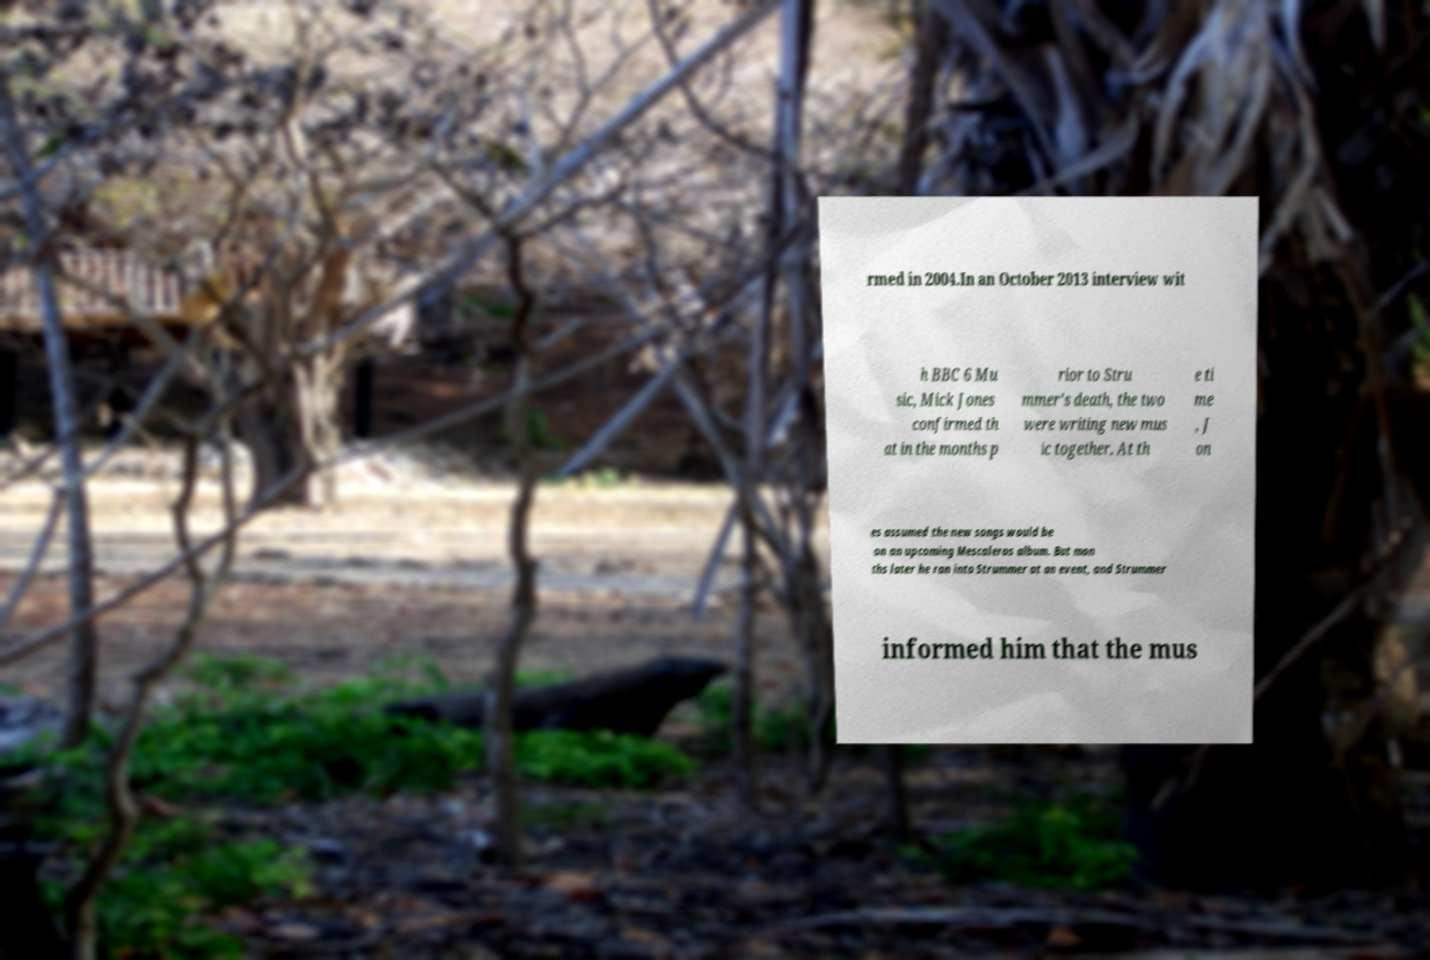Could you extract and type out the text from this image? rmed in 2004.In an October 2013 interview wit h BBC 6 Mu sic, Mick Jones confirmed th at in the months p rior to Stru mmer's death, the two were writing new mus ic together. At th e ti me , J on es assumed the new songs would be on an upcoming Mescaleros album. But mon ths later he ran into Strummer at an event, and Strummer informed him that the mus 